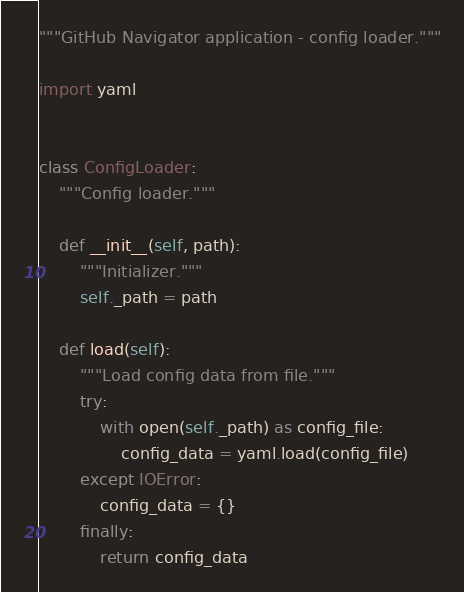Convert code to text. <code><loc_0><loc_0><loc_500><loc_500><_Python_>"""GitHub Navigator application - config loader."""

import yaml


class ConfigLoader:
    """Config loader."""

    def __init__(self, path):
        """Initializer."""
        self._path = path

    def load(self):
        """Load config data from file."""
        try:
            with open(self._path) as config_file:
                config_data = yaml.load(config_file)
        except IOError:
            config_data = {}
        finally:
            return config_data
</code> 